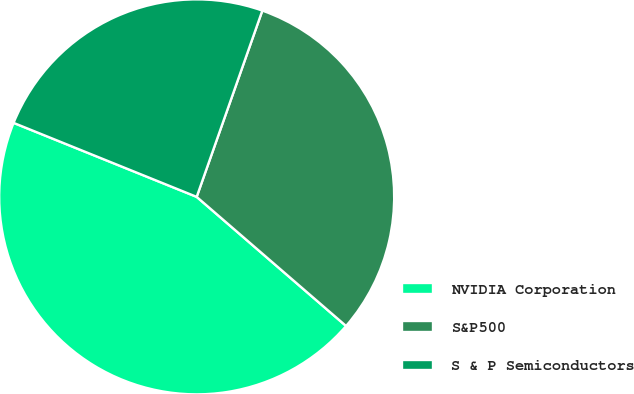<chart> <loc_0><loc_0><loc_500><loc_500><pie_chart><fcel>NVIDIA Corporation<fcel>S&P500<fcel>S & P Semiconductors<nl><fcel>44.77%<fcel>30.95%<fcel>24.28%<nl></chart> 